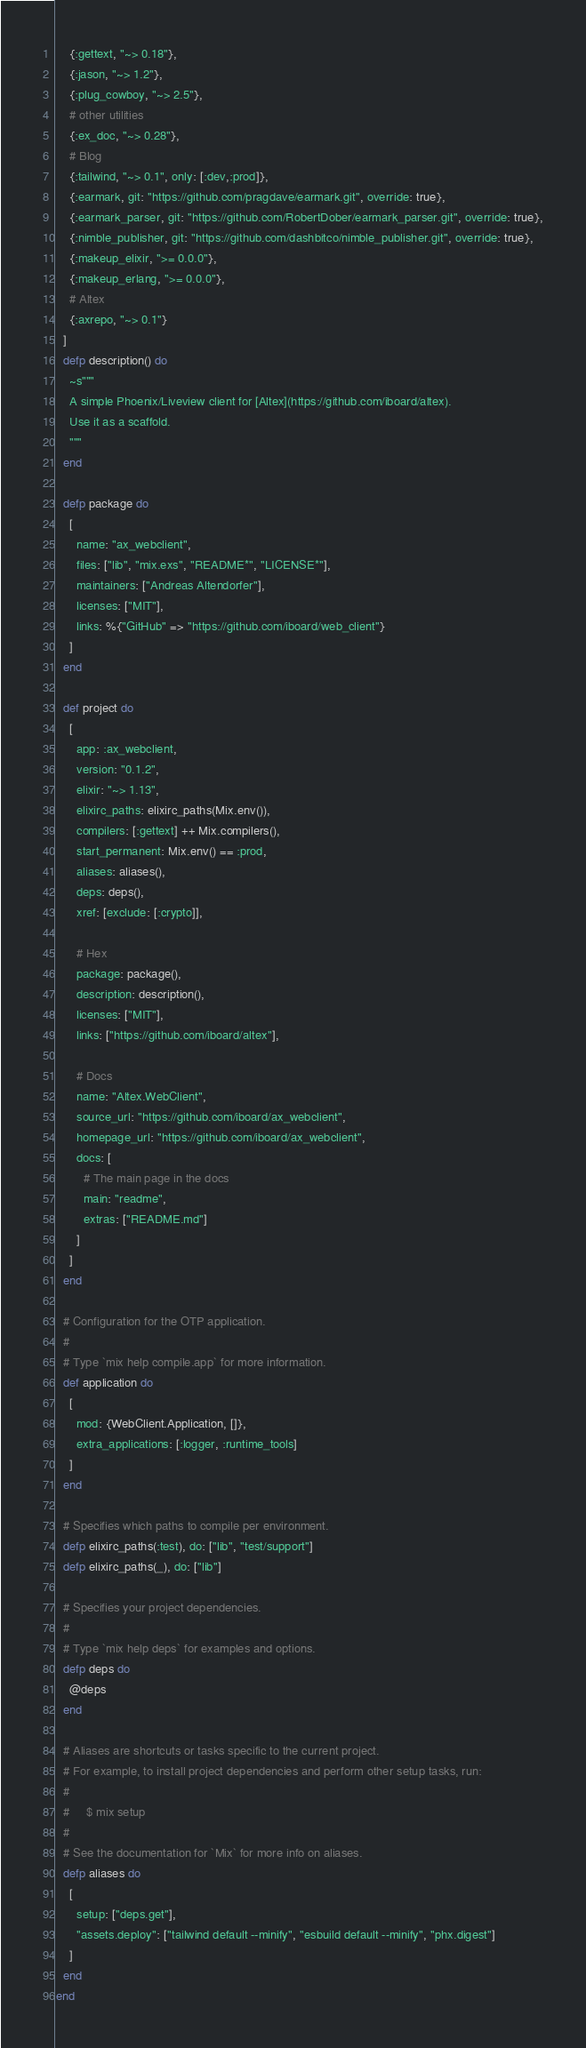Convert code to text. <code><loc_0><loc_0><loc_500><loc_500><_Elixir_>    {:gettext, "~> 0.18"},
    {:jason, "~> 1.2"},
    {:plug_cowboy, "~> 2.5"},
    # other utilities
    {:ex_doc, "~> 0.28"},
    # Blog
    {:tailwind, "~> 0.1", only: [:dev,:prod]},
    {:earmark, git: "https://github.com/pragdave/earmark.git", override: true},
    {:earmark_parser, git: "https://github.com/RobertDober/earmark_parser.git", override: true},
    {:nimble_publisher, git: "https://github.com/dashbitco/nimble_publisher.git", override: true},
    {:makeup_elixir, ">= 0.0.0"},
    {:makeup_erlang, ">= 0.0.0"},
    # Altex
    {:axrepo, "~> 0.1"}
  ]
  defp description() do
    ~s"""
    A simple Phoenix/Liveview client for [Altex](https://github.com/iboard/altex).
    Use it as a scaffold.
    """
  end

  defp package do
    [
      name: "ax_webclient",
      files: ["lib", "mix.exs", "README*", "LICENSE*"],
      maintainers: ["Andreas Altendorfer"],
      licenses: ["MIT"],
      links: %{"GitHub" => "https://github.com/iboard/web_client"}
    ]
  end

  def project do
    [
      app: :ax_webclient,
      version: "0.1.2",
      elixir: "~> 1.13",
      elixirc_paths: elixirc_paths(Mix.env()),
      compilers: [:gettext] ++ Mix.compilers(),
      start_permanent: Mix.env() == :prod,
      aliases: aliases(),
      deps: deps(),
      xref: [exclude: [:crypto]],

      # Hex
      package: package(),
      description: description(),
      licenses: ["MIT"],
      links: ["https://github.com/iboard/altex"],

      # Docs
      name: "Altex.WebClient",
      source_url: "https://github.com/iboard/ax_webclient",
      homepage_url: "https://github.com/iboard/ax_webclient",
      docs: [
        # The main page in the docs
        main: "readme",
        extras: ["README.md"]
      ]
    ]
  end

  # Configuration for the OTP application.
  #
  # Type `mix help compile.app` for more information.
  def application do
    [
      mod: {WebClient.Application, []},
      extra_applications: [:logger, :runtime_tools]
    ]
  end

  # Specifies which paths to compile per environment.
  defp elixirc_paths(:test), do: ["lib", "test/support"]
  defp elixirc_paths(_), do: ["lib"]

  # Specifies your project dependencies.
  #
  # Type `mix help deps` for examples and options.
  defp deps do
    @deps
  end

  # Aliases are shortcuts or tasks specific to the current project.
  # For example, to install project dependencies and perform other setup tasks, run:
  #
  #     $ mix setup
  #
  # See the documentation for `Mix` for more info on aliases.
  defp aliases do
    [
      setup: ["deps.get"],
      "assets.deploy": ["tailwind default --minify", "esbuild default --minify", "phx.digest"]
    ]
  end
end
</code> 